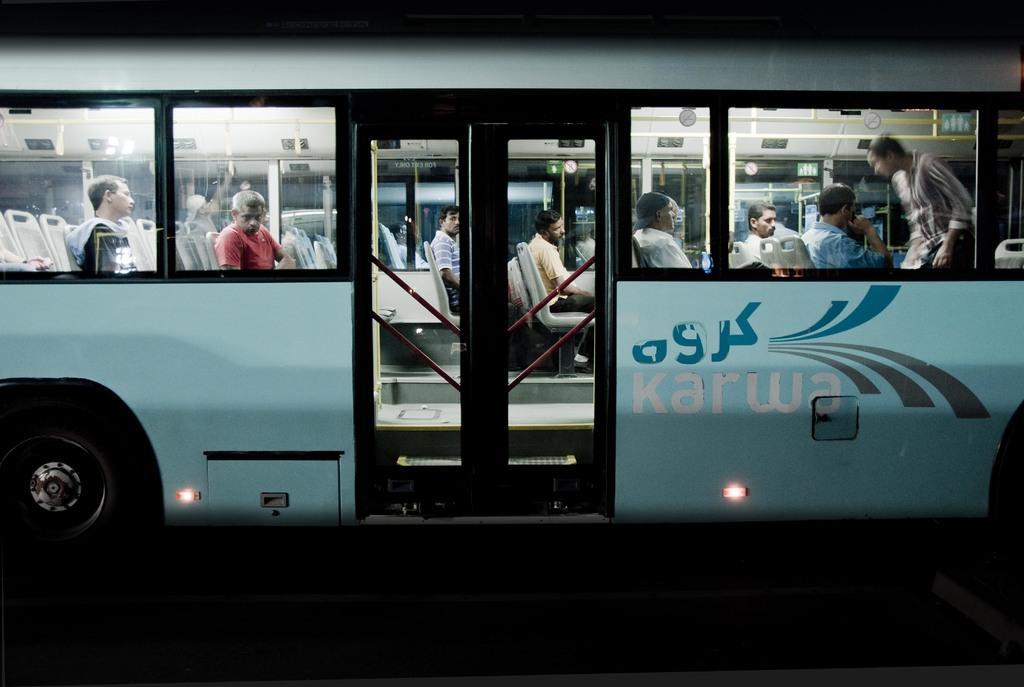Could you give a brief overview of what you see in this image? In this image there is a bus on a road, in that bus people are sitting. 